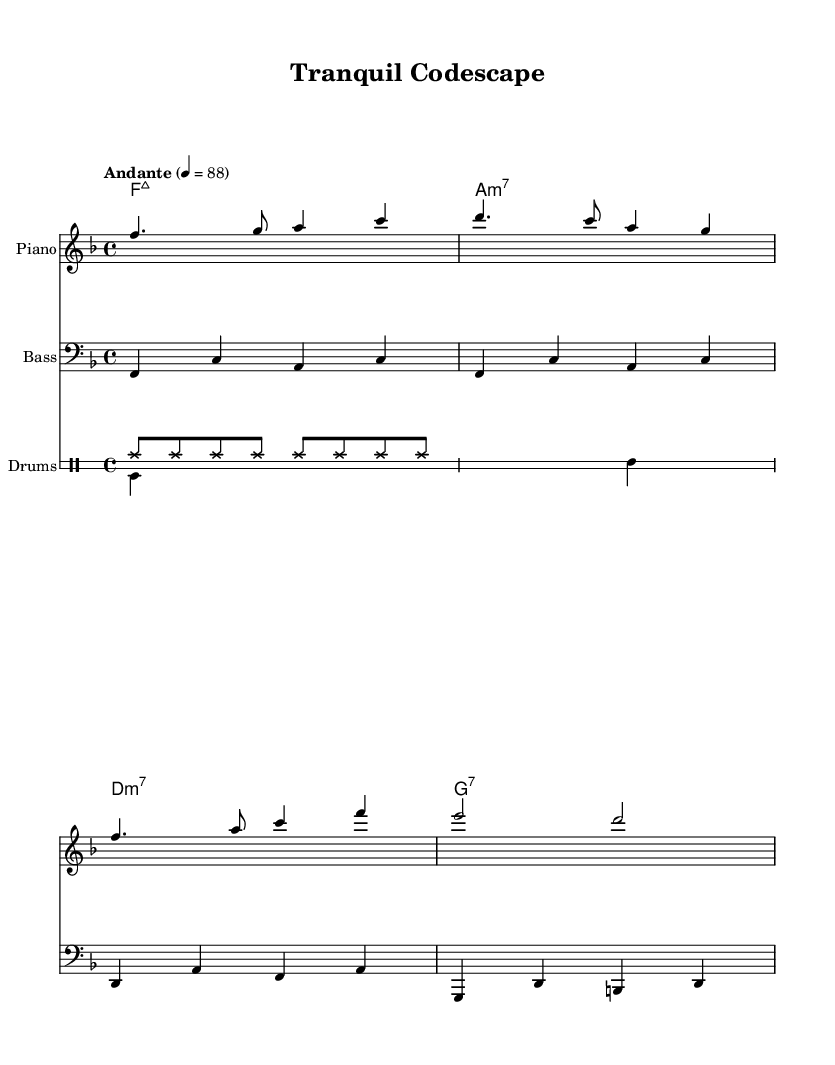What is the key signature of this music? The key signature can be determined by looking at the beginning of the staff, where there are no sharps or flats indicated. This indicates that the piece is in the key of F major.
Answer: F major What is the time signature of this piece? The time signature is found at the start of the staff and is marked as 4/4, meaning there are four beats in each measure and the quarter note gets one beat.
Answer: 4/4 What is the tempo of the music? The tempo marking is present at the beginning of the score and is indicated as "Andante" with a metronome mark of 88, meaning a moderate walking pace.
Answer: Andante 4 = 88 How many measures are in the melody? To find the number of measures, we can count the individual groups of notes within the melody section. The melody contains four measures.
Answer: 4 Which chord is played in the first measure? The first measure contains the chord indicated by the chord symbols above the staff. The chord in the first measure is F major 7.
Answer: F:maj7 What is the drum pattern in the second voice? The second drum voice can be identified in the drum staff, and by examining the notes, the pattern consists of bass drum and snare hits, which can be summarized as "s s sn s".
Answer: s s sn s How is the rhythm structured in the bassline? The bassline's rhythm can be analyzed by looking at the note values drawn in this section. It features a mix of quarter notes and half notes, leading to a relaxed bossa nova feel.
Answer: Quarter and half notes 